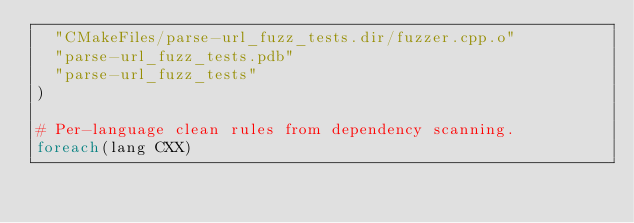Convert code to text. <code><loc_0><loc_0><loc_500><loc_500><_CMake_>  "CMakeFiles/parse-url_fuzz_tests.dir/fuzzer.cpp.o"
  "parse-url_fuzz_tests.pdb"
  "parse-url_fuzz_tests"
)

# Per-language clean rules from dependency scanning.
foreach(lang CXX)</code> 